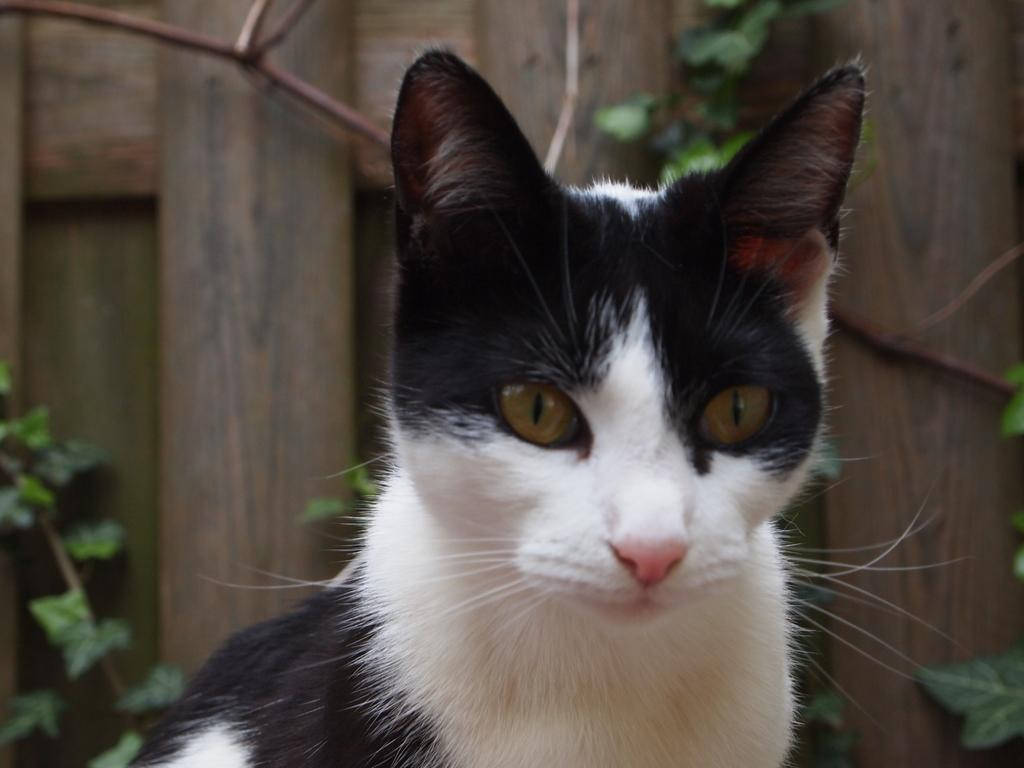What type of animal is in the image? There is a cat in the image. What can be seen in the background of the image? There is a wooden board and plants in the background of the image. What type of pipe can be seen in the image? There is no pipe present in the image. What time of day is it in the image? The time of day is not mentioned or depicted in the image. 